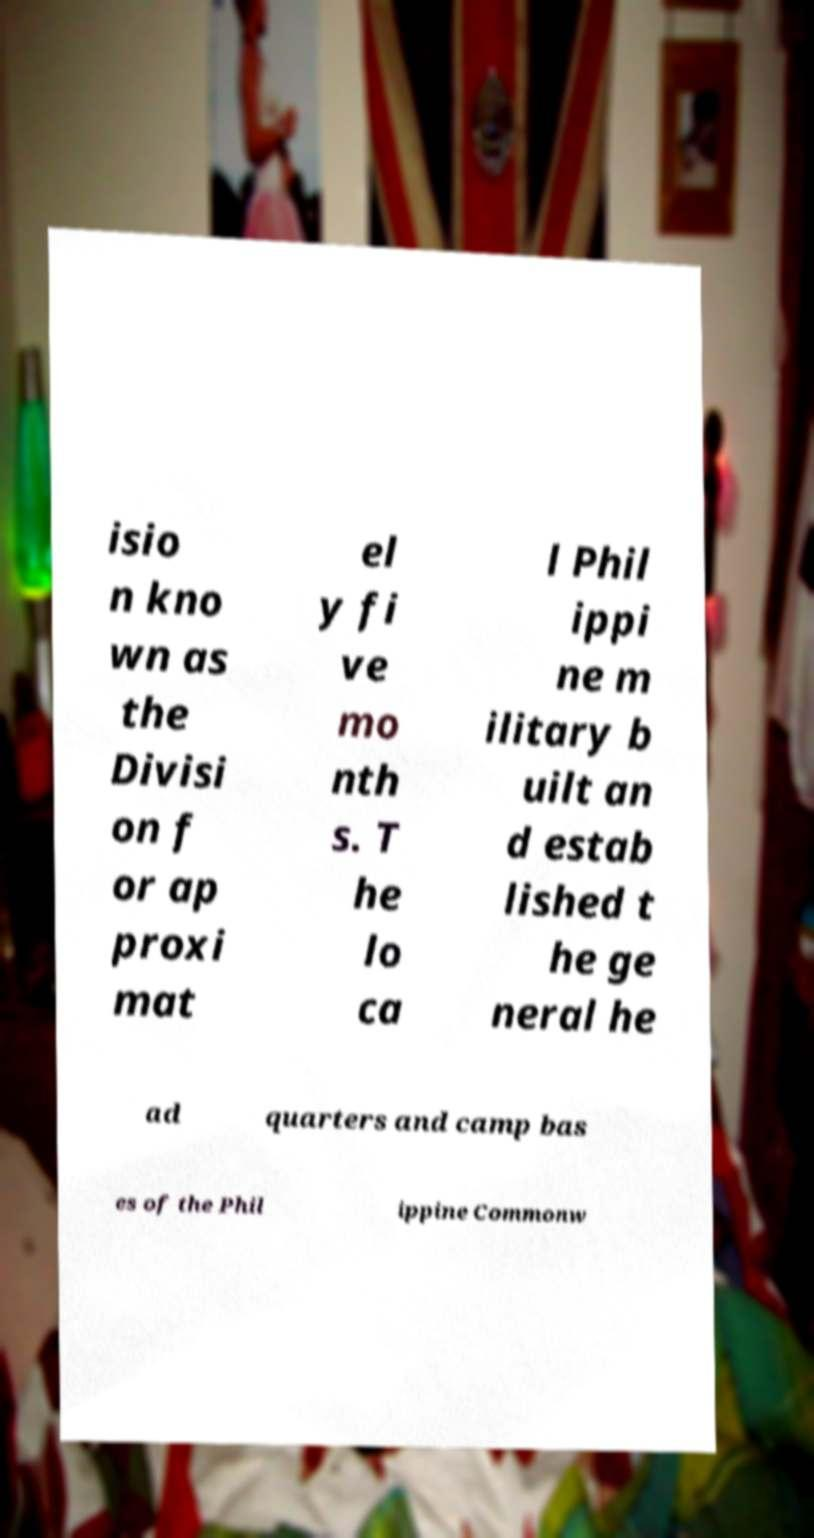Can you read and provide the text displayed in the image?This photo seems to have some interesting text. Can you extract and type it out for me? isio n kno wn as the Divisi on f or ap proxi mat el y fi ve mo nth s. T he lo ca l Phil ippi ne m ilitary b uilt an d estab lished t he ge neral he ad quarters and camp bas es of the Phil ippine Commonw 